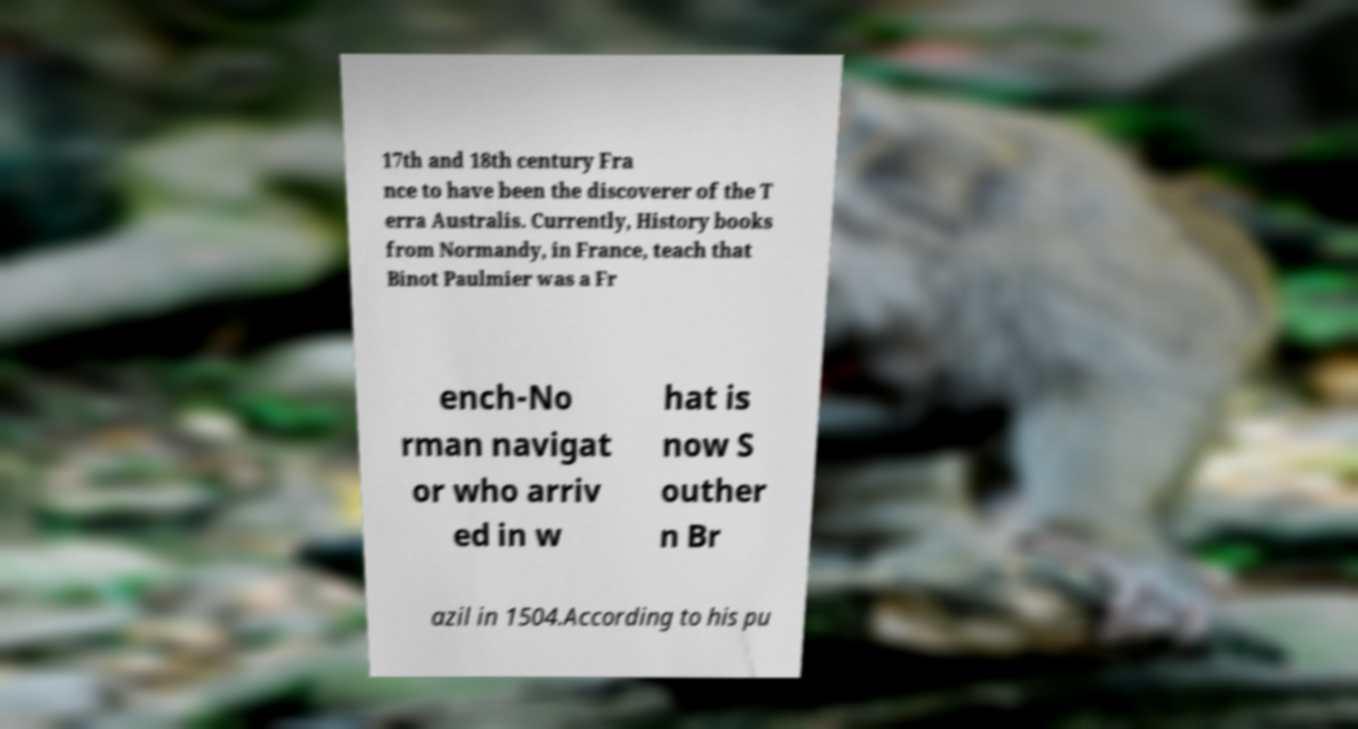I need the written content from this picture converted into text. Can you do that? 17th and 18th century Fra nce to have been the discoverer of the T erra Australis. Currently, History books from Normandy, in France, teach that Binot Paulmier was a Fr ench-No rman navigat or who arriv ed in w hat is now S outher n Br azil in 1504.According to his pu 